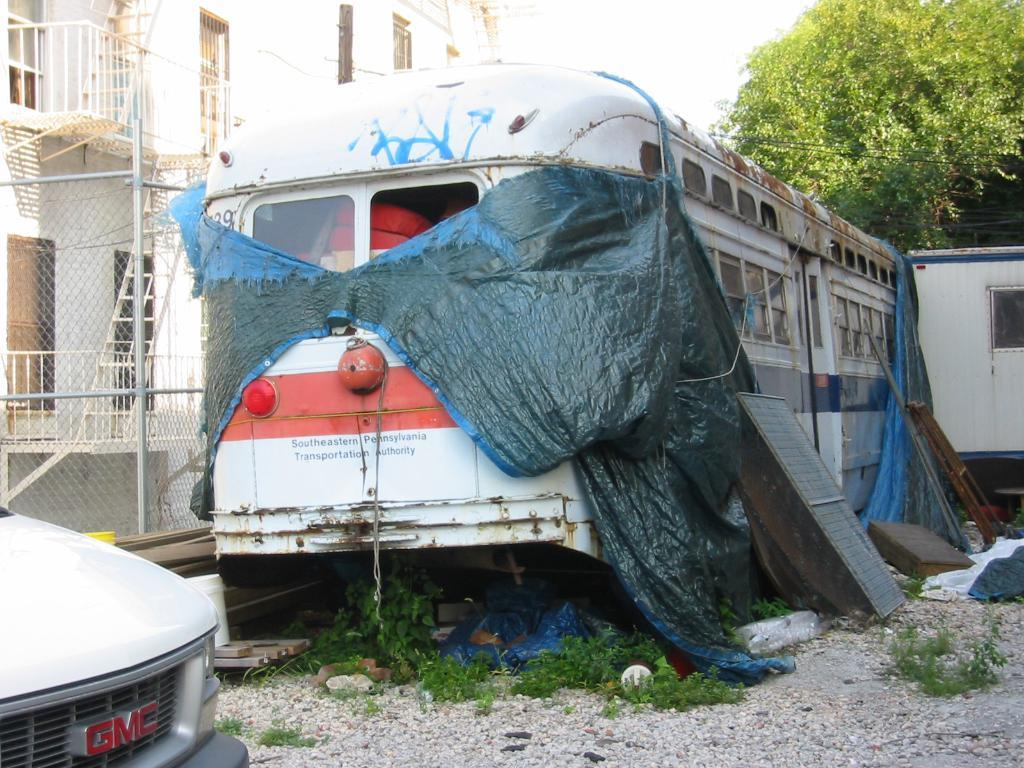What types of objects are present in the image? There are vehicles and plants in the image. What structures can be seen in the image? There is a fence in the image. What can be seen in the background of the image? There is a building, windows, and trees in the background of the image. How many times are the vehicles sorted in the image? There is no sorting of vehicles in the image; they are simply present. What type of twig can be seen in the image? There is no twig present in the image. 